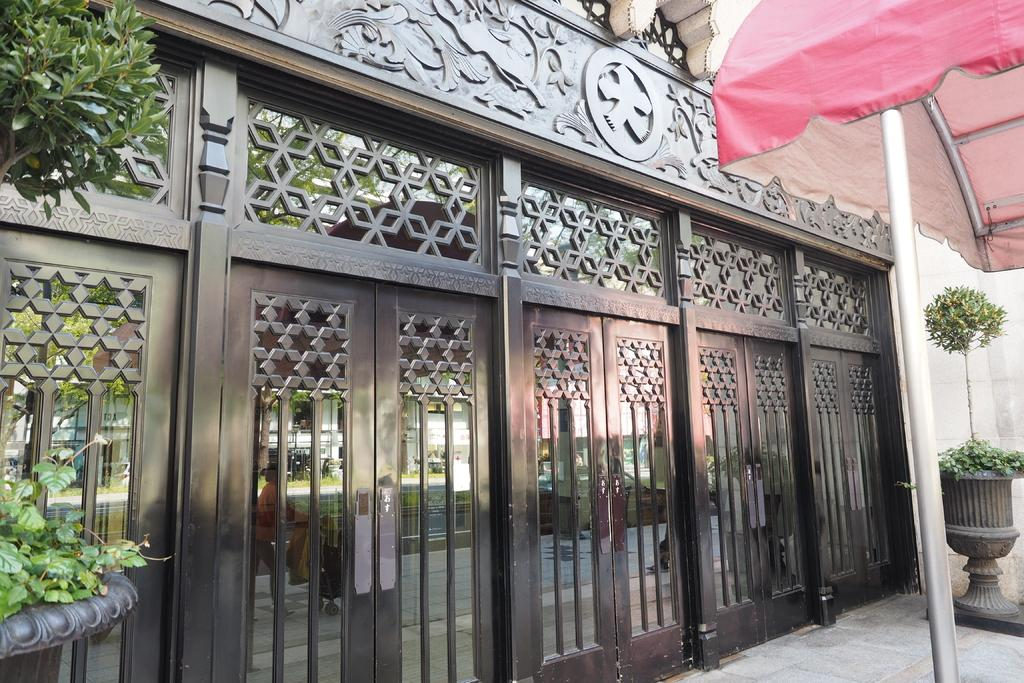What is located in front in the image? There are doors in front in the image. What type of vegetation can be seen on both sides of the image? There are plants on both sides of the image. What is on the right side of the image? There is a pole on the right side of the image. What is attached to the pole? There is a cloth on the pole. What else can be seen in the image? There are rods visible in the image. What type of education is being offered at the gate in the image? There is no gate present in the image, and no education is being offered. Can you see a card being used by someone in the image? There is no card visible in the image. 